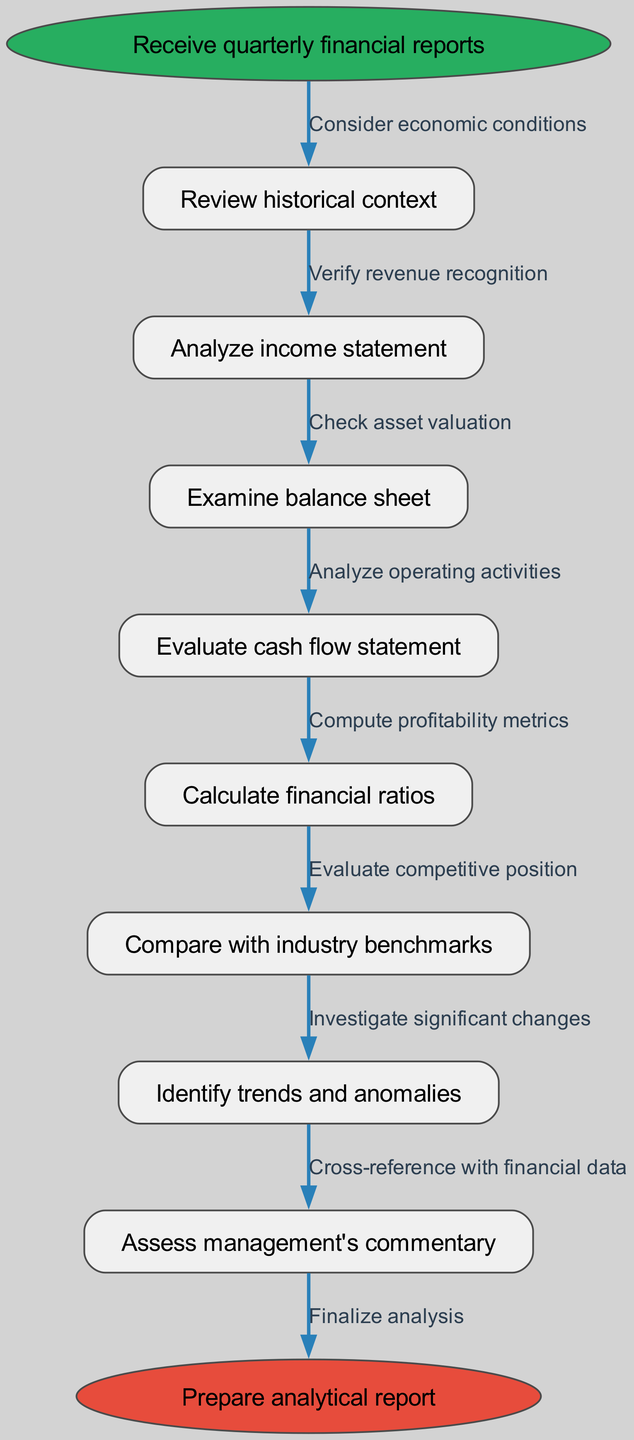What is the starting point of the workflow? The starting point is explicitly indicated at the top of the diagram as "Receive quarterly financial reports."
Answer: Receive quarterly financial reports How many main processing nodes are there? By counting the nodes listed under "nodes," there are eight main processing nodes in total.
Answer: 8 What does the last processing node evaluate? The last processing node before finalization is "Assess management's commentary," which focuses on the insights provided by management.
Answer: Assess management's commentary What edge connects the first and second nodes? The edge that connects the first node ("Review historical context") and the second node ("Analyze income statement") is labeled "Consider economic conditions."
Answer: Consider economic conditions Which node follows "Examine balance sheet"? The node that immediately follows "Examine balance sheet" in the sequence is "Evaluate cash flow statement." This shows the flow from one analysis area to another.
Answer: Evaluate cash flow statement How are financial ratios calculated in the workflow? Financial ratios are calculated after analyzing the income statement, balance sheet, and cash flow statement, showcasing a dependence on prior analyses.
Answer: After analyzing income statement, balance sheet, and cash flow statement Which two nodes are directly connected by the edge labeled "Verify revenue recognition"? The edge labeled "Verify revenue recognition" connects the "Analyze income statement" node to the "Examine balance sheet" node, highlighting an important verification step in the workflow.
Answer: Analyze income statement and Examine balance sheet What does the diagram suggest comes after identifying trends and anomalies? After identifying trends and anomalies, the next step in the workflow is "Assess management's commentary," indicating a need for qualitative assessment after quantitative analysis.
Answer: Assess management's commentary 